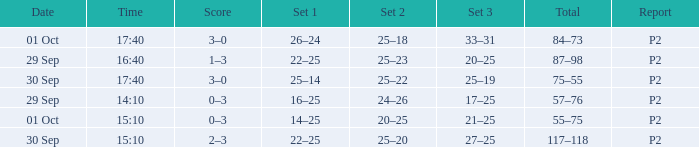What Score has a time of 14:10? 0–3. 